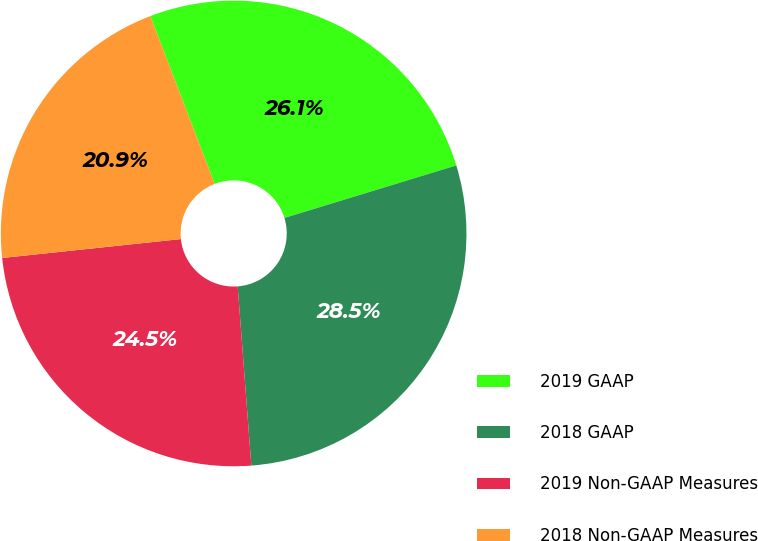Convert chart to OTSL. <chart><loc_0><loc_0><loc_500><loc_500><pie_chart><fcel>2019 GAAP<fcel>2018 GAAP<fcel>2019 Non-GAAP Measures<fcel>2018 Non-GAAP Measures<nl><fcel>26.11%<fcel>28.51%<fcel>24.53%<fcel>20.85%<nl></chart> 